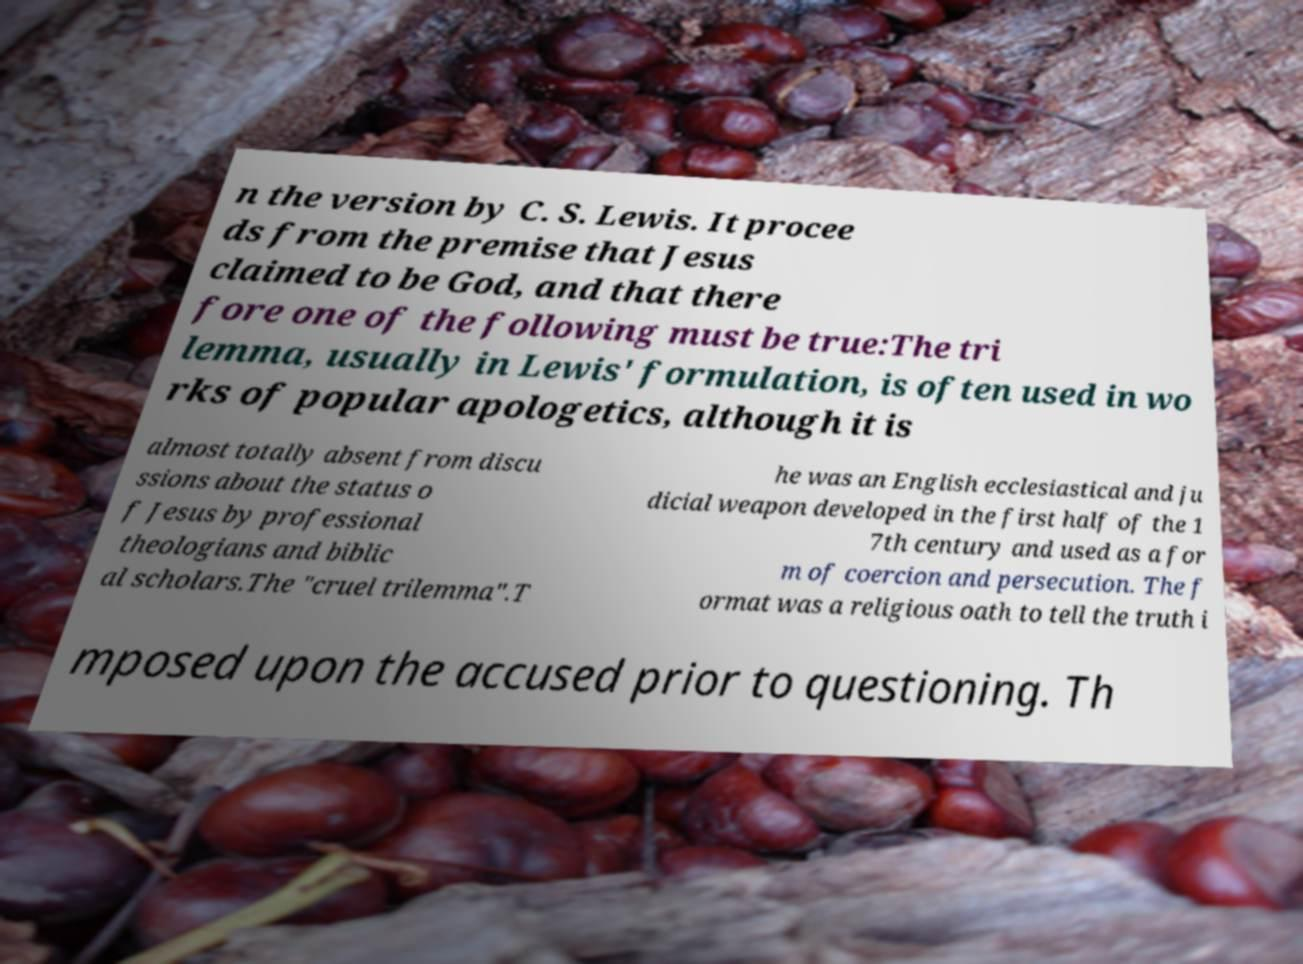For documentation purposes, I need the text within this image transcribed. Could you provide that? n the version by C. S. Lewis. It procee ds from the premise that Jesus claimed to be God, and that there fore one of the following must be true:The tri lemma, usually in Lewis' formulation, is often used in wo rks of popular apologetics, although it is almost totally absent from discu ssions about the status o f Jesus by professional theologians and biblic al scholars.The "cruel trilemma".T he was an English ecclesiastical and ju dicial weapon developed in the first half of the 1 7th century and used as a for m of coercion and persecution. The f ormat was a religious oath to tell the truth i mposed upon the accused prior to questioning. Th 